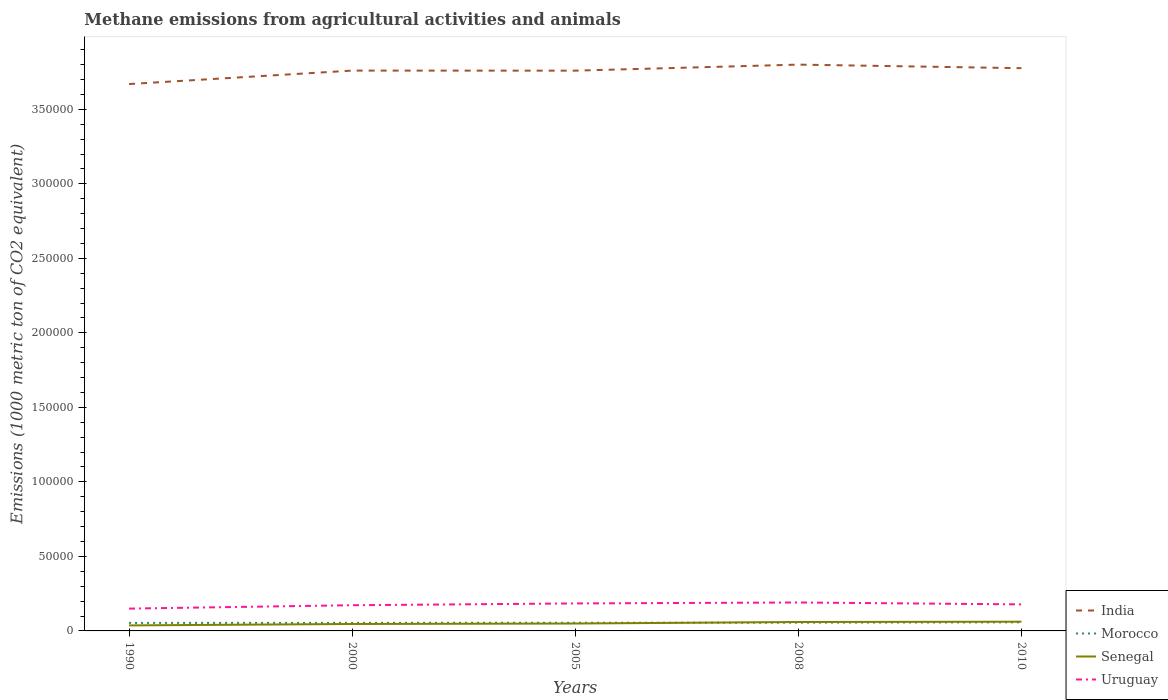Is the number of lines equal to the number of legend labels?
Your answer should be compact. Yes. Across all years, what is the maximum amount of methane emitted in India?
Your answer should be very brief. 3.67e+05. In which year was the amount of methane emitted in India maximum?
Offer a terse response. 1990. What is the total amount of methane emitted in Senegal in the graph?
Provide a short and direct response. -1029.8. What is the difference between the highest and the second highest amount of methane emitted in Uruguay?
Ensure brevity in your answer.  4108.2. What is the difference between the highest and the lowest amount of methane emitted in India?
Your answer should be compact. 4. What is the difference between two consecutive major ticks on the Y-axis?
Your response must be concise. 5.00e+04. Are the values on the major ticks of Y-axis written in scientific E-notation?
Make the answer very short. No. What is the title of the graph?
Your response must be concise. Methane emissions from agricultural activities and animals. Does "Tunisia" appear as one of the legend labels in the graph?
Provide a succinct answer. No. What is the label or title of the Y-axis?
Provide a succinct answer. Emissions (1000 metric ton of CO2 equivalent). What is the Emissions (1000 metric ton of CO2 equivalent) of India in 1990?
Your answer should be very brief. 3.67e+05. What is the Emissions (1000 metric ton of CO2 equivalent) in Morocco in 1990?
Ensure brevity in your answer.  5368.8. What is the Emissions (1000 metric ton of CO2 equivalent) of Senegal in 1990?
Provide a short and direct response. 3695.6. What is the Emissions (1000 metric ton of CO2 equivalent) of Uruguay in 1990?
Make the answer very short. 1.50e+04. What is the Emissions (1000 metric ton of CO2 equivalent) in India in 2000?
Provide a short and direct response. 3.76e+05. What is the Emissions (1000 metric ton of CO2 equivalent) in Morocco in 2000?
Offer a terse response. 5400.3. What is the Emissions (1000 metric ton of CO2 equivalent) in Senegal in 2000?
Your answer should be compact. 4650.7. What is the Emissions (1000 metric ton of CO2 equivalent) in Uruguay in 2000?
Offer a terse response. 1.72e+04. What is the Emissions (1000 metric ton of CO2 equivalent) in India in 2005?
Your answer should be compact. 3.76e+05. What is the Emissions (1000 metric ton of CO2 equivalent) in Morocco in 2005?
Your answer should be very brief. 5471.4. What is the Emissions (1000 metric ton of CO2 equivalent) in Senegal in 2005?
Keep it short and to the point. 4955.1. What is the Emissions (1000 metric ton of CO2 equivalent) of Uruguay in 2005?
Offer a very short reply. 1.84e+04. What is the Emissions (1000 metric ton of CO2 equivalent) of India in 2008?
Your response must be concise. 3.80e+05. What is the Emissions (1000 metric ton of CO2 equivalent) of Morocco in 2008?
Your answer should be compact. 5546.4. What is the Emissions (1000 metric ton of CO2 equivalent) in Senegal in 2008?
Keep it short and to the point. 5984.9. What is the Emissions (1000 metric ton of CO2 equivalent) of Uruguay in 2008?
Provide a short and direct response. 1.91e+04. What is the Emissions (1000 metric ton of CO2 equivalent) in India in 2010?
Make the answer very short. 3.78e+05. What is the Emissions (1000 metric ton of CO2 equivalent) of Morocco in 2010?
Offer a very short reply. 5779.1. What is the Emissions (1000 metric ton of CO2 equivalent) in Senegal in 2010?
Ensure brevity in your answer.  6199.1. What is the Emissions (1000 metric ton of CO2 equivalent) in Uruguay in 2010?
Your answer should be very brief. 1.78e+04. Across all years, what is the maximum Emissions (1000 metric ton of CO2 equivalent) in India?
Make the answer very short. 3.80e+05. Across all years, what is the maximum Emissions (1000 metric ton of CO2 equivalent) in Morocco?
Offer a very short reply. 5779.1. Across all years, what is the maximum Emissions (1000 metric ton of CO2 equivalent) in Senegal?
Provide a short and direct response. 6199.1. Across all years, what is the maximum Emissions (1000 metric ton of CO2 equivalent) of Uruguay?
Make the answer very short. 1.91e+04. Across all years, what is the minimum Emissions (1000 metric ton of CO2 equivalent) in India?
Provide a succinct answer. 3.67e+05. Across all years, what is the minimum Emissions (1000 metric ton of CO2 equivalent) of Morocco?
Your answer should be compact. 5368.8. Across all years, what is the minimum Emissions (1000 metric ton of CO2 equivalent) of Senegal?
Keep it short and to the point. 3695.6. Across all years, what is the minimum Emissions (1000 metric ton of CO2 equivalent) in Uruguay?
Offer a terse response. 1.50e+04. What is the total Emissions (1000 metric ton of CO2 equivalent) in India in the graph?
Offer a terse response. 1.88e+06. What is the total Emissions (1000 metric ton of CO2 equivalent) of Morocco in the graph?
Provide a succinct answer. 2.76e+04. What is the total Emissions (1000 metric ton of CO2 equivalent) of Senegal in the graph?
Give a very brief answer. 2.55e+04. What is the total Emissions (1000 metric ton of CO2 equivalent) of Uruguay in the graph?
Keep it short and to the point. 8.75e+04. What is the difference between the Emissions (1000 metric ton of CO2 equivalent) of India in 1990 and that in 2000?
Ensure brevity in your answer.  -9029.4. What is the difference between the Emissions (1000 metric ton of CO2 equivalent) in Morocco in 1990 and that in 2000?
Give a very brief answer. -31.5. What is the difference between the Emissions (1000 metric ton of CO2 equivalent) of Senegal in 1990 and that in 2000?
Your answer should be very brief. -955.1. What is the difference between the Emissions (1000 metric ton of CO2 equivalent) in Uruguay in 1990 and that in 2000?
Offer a terse response. -2267.7. What is the difference between the Emissions (1000 metric ton of CO2 equivalent) of India in 1990 and that in 2005?
Ensure brevity in your answer.  -8983.7. What is the difference between the Emissions (1000 metric ton of CO2 equivalent) in Morocco in 1990 and that in 2005?
Provide a succinct answer. -102.6. What is the difference between the Emissions (1000 metric ton of CO2 equivalent) in Senegal in 1990 and that in 2005?
Make the answer very short. -1259.5. What is the difference between the Emissions (1000 metric ton of CO2 equivalent) in Uruguay in 1990 and that in 2005?
Ensure brevity in your answer.  -3472.5. What is the difference between the Emissions (1000 metric ton of CO2 equivalent) of India in 1990 and that in 2008?
Your answer should be very brief. -1.30e+04. What is the difference between the Emissions (1000 metric ton of CO2 equivalent) of Morocco in 1990 and that in 2008?
Your answer should be very brief. -177.6. What is the difference between the Emissions (1000 metric ton of CO2 equivalent) of Senegal in 1990 and that in 2008?
Give a very brief answer. -2289.3. What is the difference between the Emissions (1000 metric ton of CO2 equivalent) of Uruguay in 1990 and that in 2008?
Keep it short and to the point. -4108.2. What is the difference between the Emissions (1000 metric ton of CO2 equivalent) in India in 1990 and that in 2010?
Offer a very short reply. -1.06e+04. What is the difference between the Emissions (1000 metric ton of CO2 equivalent) in Morocco in 1990 and that in 2010?
Give a very brief answer. -410.3. What is the difference between the Emissions (1000 metric ton of CO2 equivalent) in Senegal in 1990 and that in 2010?
Offer a very short reply. -2503.5. What is the difference between the Emissions (1000 metric ton of CO2 equivalent) of Uruguay in 1990 and that in 2010?
Offer a very short reply. -2833.1. What is the difference between the Emissions (1000 metric ton of CO2 equivalent) in India in 2000 and that in 2005?
Offer a terse response. 45.7. What is the difference between the Emissions (1000 metric ton of CO2 equivalent) of Morocco in 2000 and that in 2005?
Provide a short and direct response. -71.1. What is the difference between the Emissions (1000 metric ton of CO2 equivalent) in Senegal in 2000 and that in 2005?
Offer a terse response. -304.4. What is the difference between the Emissions (1000 metric ton of CO2 equivalent) of Uruguay in 2000 and that in 2005?
Provide a succinct answer. -1204.8. What is the difference between the Emissions (1000 metric ton of CO2 equivalent) in India in 2000 and that in 2008?
Provide a succinct answer. -4005.8. What is the difference between the Emissions (1000 metric ton of CO2 equivalent) in Morocco in 2000 and that in 2008?
Make the answer very short. -146.1. What is the difference between the Emissions (1000 metric ton of CO2 equivalent) of Senegal in 2000 and that in 2008?
Offer a very short reply. -1334.2. What is the difference between the Emissions (1000 metric ton of CO2 equivalent) of Uruguay in 2000 and that in 2008?
Ensure brevity in your answer.  -1840.5. What is the difference between the Emissions (1000 metric ton of CO2 equivalent) of India in 2000 and that in 2010?
Offer a terse response. -1614.3. What is the difference between the Emissions (1000 metric ton of CO2 equivalent) of Morocco in 2000 and that in 2010?
Your answer should be very brief. -378.8. What is the difference between the Emissions (1000 metric ton of CO2 equivalent) in Senegal in 2000 and that in 2010?
Keep it short and to the point. -1548.4. What is the difference between the Emissions (1000 metric ton of CO2 equivalent) of Uruguay in 2000 and that in 2010?
Your answer should be very brief. -565.4. What is the difference between the Emissions (1000 metric ton of CO2 equivalent) in India in 2005 and that in 2008?
Provide a short and direct response. -4051.5. What is the difference between the Emissions (1000 metric ton of CO2 equivalent) in Morocco in 2005 and that in 2008?
Your answer should be very brief. -75. What is the difference between the Emissions (1000 metric ton of CO2 equivalent) in Senegal in 2005 and that in 2008?
Make the answer very short. -1029.8. What is the difference between the Emissions (1000 metric ton of CO2 equivalent) of Uruguay in 2005 and that in 2008?
Your response must be concise. -635.7. What is the difference between the Emissions (1000 metric ton of CO2 equivalent) of India in 2005 and that in 2010?
Your response must be concise. -1660. What is the difference between the Emissions (1000 metric ton of CO2 equivalent) of Morocco in 2005 and that in 2010?
Offer a terse response. -307.7. What is the difference between the Emissions (1000 metric ton of CO2 equivalent) of Senegal in 2005 and that in 2010?
Offer a very short reply. -1244. What is the difference between the Emissions (1000 metric ton of CO2 equivalent) of Uruguay in 2005 and that in 2010?
Give a very brief answer. 639.4. What is the difference between the Emissions (1000 metric ton of CO2 equivalent) of India in 2008 and that in 2010?
Offer a very short reply. 2391.5. What is the difference between the Emissions (1000 metric ton of CO2 equivalent) of Morocco in 2008 and that in 2010?
Your response must be concise. -232.7. What is the difference between the Emissions (1000 metric ton of CO2 equivalent) in Senegal in 2008 and that in 2010?
Ensure brevity in your answer.  -214.2. What is the difference between the Emissions (1000 metric ton of CO2 equivalent) in Uruguay in 2008 and that in 2010?
Offer a terse response. 1275.1. What is the difference between the Emissions (1000 metric ton of CO2 equivalent) of India in 1990 and the Emissions (1000 metric ton of CO2 equivalent) of Morocco in 2000?
Ensure brevity in your answer.  3.62e+05. What is the difference between the Emissions (1000 metric ton of CO2 equivalent) of India in 1990 and the Emissions (1000 metric ton of CO2 equivalent) of Senegal in 2000?
Your response must be concise. 3.62e+05. What is the difference between the Emissions (1000 metric ton of CO2 equivalent) of India in 1990 and the Emissions (1000 metric ton of CO2 equivalent) of Uruguay in 2000?
Your answer should be compact. 3.50e+05. What is the difference between the Emissions (1000 metric ton of CO2 equivalent) in Morocco in 1990 and the Emissions (1000 metric ton of CO2 equivalent) in Senegal in 2000?
Make the answer very short. 718.1. What is the difference between the Emissions (1000 metric ton of CO2 equivalent) of Morocco in 1990 and the Emissions (1000 metric ton of CO2 equivalent) of Uruguay in 2000?
Keep it short and to the point. -1.19e+04. What is the difference between the Emissions (1000 metric ton of CO2 equivalent) of Senegal in 1990 and the Emissions (1000 metric ton of CO2 equivalent) of Uruguay in 2000?
Offer a very short reply. -1.35e+04. What is the difference between the Emissions (1000 metric ton of CO2 equivalent) of India in 1990 and the Emissions (1000 metric ton of CO2 equivalent) of Morocco in 2005?
Keep it short and to the point. 3.61e+05. What is the difference between the Emissions (1000 metric ton of CO2 equivalent) in India in 1990 and the Emissions (1000 metric ton of CO2 equivalent) in Senegal in 2005?
Your response must be concise. 3.62e+05. What is the difference between the Emissions (1000 metric ton of CO2 equivalent) in India in 1990 and the Emissions (1000 metric ton of CO2 equivalent) in Uruguay in 2005?
Provide a succinct answer. 3.48e+05. What is the difference between the Emissions (1000 metric ton of CO2 equivalent) of Morocco in 1990 and the Emissions (1000 metric ton of CO2 equivalent) of Senegal in 2005?
Your answer should be compact. 413.7. What is the difference between the Emissions (1000 metric ton of CO2 equivalent) of Morocco in 1990 and the Emissions (1000 metric ton of CO2 equivalent) of Uruguay in 2005?
Offer a terse response. -1.31e+04. What is the difference between the Emissions (1000 metric ton of CO2 equivalent) of Senegal in 1990 and the Emissions (1000 metric ton of CO2 equivalent) of Uruguay in 2005?
Your response must be concise. -1.48e+04. What is the difference between the Emissions (1000 metric ton of CO2 equivalent) of India in 1990 and the Emissions (1000 metric ton of CO2 equivalent) of Morocco in 2008?
Your answer should be compact. 3.61e+05. What is the difference between the Emissions (1000 metric ton of CO2 equivalent) of India in 1990 and the Emissions (1000 metric ton of CO2 equivalent) of Senegal in 2008?
Give a very brief answer. 3.61e+05. What is the difference between the Emissions (1000 metric ton of CO2 equivalent) of India in 1990 and the Emissions (1000 metric ton of CO2 equivalent) of Uruguay in 2008?
Your answer should be compact. 3.48e+05. What is the difference between the Emissions (1000 metric ton of CO2 equivalent) of Morocco in 1990 and the Emissions (1000 metric ton of CO2 equivalent) of Senegal in 2008?
Your response must be concise. -616.1. What is the difference between the Emissions (1000 metric ton of CO2 equivalent) of Morocco in 1990 and the Emissions (1000 metric ton of CO2 equivalent) of Uruguay in 2008?
Give a very brief answer. -1.37e+04. What is the difference between the Emissions (1000 metric ton of CO2 equivalent) of Senegal in 1990 and the Emissions (1000 metric ton of CO2 equivalent) of Uruguay in 2008?
Provide a short and direct response. -1.54e+04. What is the difference between the Emissions (1000 metric ton of CO2 equivalent) in India in 1990 and the Emissions (1000 metric ton of CO2 equivalent) in Morocco in 2010?
Keep it short and to the point. 3.61e+05. What is the difference between the Emissions (1000 metric ton of CO2 equivalent) in India in 1990 and the Emissions (1000 metric ton of CO2 equivalent) in Senegal in 2010?
Offer a very short reply. 3.61e+05. What is the difference between the Emissions (1000 metric ton of CO2 equivalent) of India in 1990 and the Emissions (1000 metric ton of CO2 equivalent) of Uruguay in 2010?
Provide a short and direct response. 3.49e+05. What is the difference between the Emissions (1000 metric ton of CO2 equivalent) of Morocco in 1990 and the Emissions (1000 metric ton of CO2 equivalent) of Senegal in 2010?
Make the answer very short. -830.3. What is the difference between the Emissions (1000 metric ton of CO2 equivalent) of Morocco in 1990 and the Emissions (1000 metric ton of CO2 equivalent) of Uruguay in 2010?
Ensure brevity in your answer.  -1.24e+04. What is the difference between the Emissions (1000 metric ton of CO2 equivalent) in Senegal in 1990 and the Emissions (1000 metric ton of CO2 equivalent) in Uruguay in 2010?
Your answer should be very brief. -1.41e+04. What is the difference between the Emissions (1000 metric ton of CO2 equivalent) of India in 2000 and the Emissions (1000 metric ton of CO2 equivalent) of Morocco in 2005?
Offer a terse response. 3.71e+05. What is the difference between the Emissions (1000 metric ton of CO2 equivalent) of India in 2000 and the Emissions (1000 metric ton of CO2 equivalent) of Senegal in 2005?
Keep it short and to the point. 3.71e+05. What is the difference between the Emissions (1000 metric ton of CO2 equivalent) of India in 2000 and the Emissions (1000 metric ton of CO2 equivalent) of Uruguay in 2005?
Your answer should be compact. 3.58e+05. What is the difference between the Emissions (1000 metric ton of CO2 equivalent) of Morocco in 2000 and the Emissions (1000 metric ton of CO2 equivalent) of Senegal in 2005?
Your answer should be very brief. 445.2. What is the difference between the Emissions (1000 metric ton of CO2 equivalent) in Morocco in 2000 and the Emissions (1000 metric ton of CO2 equivalent) in Uruguay in 2005?
Offer a terse response. -1.30e+04. What is the difference between the Emissions (1000 metric ton of CO2 equivalent) in Senegal in 2000 and the Emissions (1000 metric ton of CO2 equivalent) in Uruguay in 2005?
Keep it short and to the point. -1.38e+04. What is the difference between the Emissions (1000 metric ton of CO2 equivalent) of India in 2000 and the Emissions (1000 metric ton of CO2 equivalent) of Morocco in 2008?
Offer a terse response. 3.70e+05. What is the difference between the Emissions (1000 metric ton of CO2 equivalent) in India in 2000 and the Emissions (1000 metric ton of CO2 equivalent) in Senegal in 2008?
Your answer should be compact. 3.70e+05. What is the difference between the Emissions (1000 metric ton of CO2 equivalent) of India in 2000 and the Emissions (1000 metric ton of CO2 equivalent) of Uruguay in 2008?
Offer a very short reply. 3.57e+05. What is the difference between the Emissions (1000 metric ton of CO2 equivalent) in Morocco in 2000 and the Emissions (1000 metric ton of CO2 equivalent) in Senegal in 2008?
Offer a terse response. -584.6. What is the difference between the Emissions (1000 metric ton of CO2 equivalent) of Morocco in 2000 and the Emissions (1000 metric ton of CO2 equivalent) of Uruguay in 2008?
Your response must be concise. -1.37e+04. What is the difference between the Emissions (1000 metric ton of CO2 equivalent) in Senegal in 2000 and the Emissions (1000 metric ton of CO2 equivalent) in Uruguay in 2008?
Ensure brevity in your answer.  -1.44e+04. What is the difference between the Emissions (1000 metric ton of CO2 equivalent) in India in 2000 and the Emissions (1000 metric ton of CO2 equivalent) in Morocco in 2010?
Give a very brief answer. 3.70e+05. What is the difference between the Emissions (1000 metric ton of CO2 equivalent) in India in 2000 and the Emissions (1000 metric ton of CO2 equivalent) in Senegal in 2010?
Provide a succinct answer. 3.70e+05. What is the difference between the Emissions (1000 metric ton of CO2 equivalent) of India in 2000 and the Emissions (1000 metric ton of CO2 equivalent) of Uruguay in 2010?
Give a very brief answer. 3.58e+05. What is the difference between the Emissions (1000 metric ton of CO2 equivalent) of Morocco in 2000 and the Emissions (1000 metric ton of CO2 equivalent) of Senegal in 2010?
Offer a very short reply. -798.8. What is the difference between the Emissions (1000 metric ton of CO2 equivalent) in Morocco in 2000 and the Emissions (1000 metric ton of CO2 equivalent) in Uruguay in 2010?
Make the answer very short. -1.24e+04. What is the difference between the Emissions (1000 metric ton of CO2 equivalent) in Senegal in 2000 and the Emissions (1000 metric ton of CO2 equivalent) in Uruguay in 2010?
Offer a very short reply. -1.32e+04. What is the difference between the Emissions (1000 metric ton of CO2 equivalent) in India in 2005 and the Emissions (1000 metric ton of CO2 equivalent) in Morocco in 2008?
Provide a succinct answer. 3.70e+05. What is the difference between the Emissions (1000 metric ton of CO2 equivalent) in India in 2005 and the Emissions (1000 metric ton of CO2 equivalent) in Senegal in 2008?
Give a very brief answer. 3.70e+05. What is the difference between the Emissions (1000 metric ton of CO2 equivalent) of India in 2005 and the Emissions (1000 metric ton of CO2 equivalent) of Uruguay in 2008?
Provide a short and direct response. 3.57e+05. What is the difference between the Emissions (1000 metric ton of CO2 equivalent) of Morocco in 2005 and the Emissions (1000 metric ton of CO2 equivalent) of Senegal in 2008?
Make the answer very short. -513.5. What is the difference between the Emissions (1000 metric ton of CO2 equivalent) of Morocco in 2005 and the Emissions (1000 metric ton of CO2 equivalent) of Uruguay in 2008?
Offer a terse response. -1.36e+04. What is the difference between the Emissions (1000 metric ton of CO2 equivalent) in Senegal in 2005 and the Emissions (1000 metric ton of CO2 equivalent) in Uruguay in 2008?
Your answer should be very brief. -1.41e+04. What is the difference between the Emissions (1000 metric ton of CO2 equivalent) in India in 2005 and the Emissions (1000 metric ton of CO2 equivalent) in Morocco in 2010?
Ensure brevity in your answer.  3.70e+05. What is the difference between the Emissions (1000 metric ton of CO2 equivalent) in India in 2005 and the Emissions (1000 metric ton of CO2 equivalent) in Senegal in 2010?
Your answer should be compact. 3.70e+05. What is the difference between the Emissions (1000 metric ton of CO2 equivalent) of India in 2005 and the Emissions (1000 metric ton of CO2 equivalent) of Uruguay in 2010?
Provide a short and direct response. 3.58e+05. What is the difference between the Emissions (1000 metric ton of CO2 equivalent) of Morocco in 2005 and the Emissions (1000 metric ton of CO2 equivalent) of Senegal in 2010?
Make the answer very short. -727.7. What is the difference between the Emissions (1000 metric ton of CO2 equivalent) of Morocco in 2005 and the Emissions (1000 metric ton of CO2 equivalent) of Uruguay in 2010?
Your response must be concise. -1.23e+04. What is the difference between the Emissions (1000 metric ton of CO2 equivalent) of Senegal in 2005 and the Emissions (1000 metric ton of CO2 equivalent) of Uruguay in 2010?
Offer a very short reply. -1.29e+04. What is the difference between the Emissions (1000 metric ton of CO2 equivalent) in India in 2008 and the Emissions (1000 metric ton of CO2 equivalent) in Morocco in 2010?
Your response must be concise. 3.74e+05. What is the difference between the Emissions (1000 metric ton of CO2 equivalent) in India in 2008 and the Emissions (1000 metric ton of CO2 equivalent) in Senegal in 2010?
Make the answer very short. 3.74e+05. What is the difference between the Emissions (1000 metric ton of CO2 equivalent) of India in 2008 and the Emissions (1000 metric ton of CO2 equivalent) of Uruguay in 2010?
Make the answer very short. 3.62e+05. What is the difference between the Emissions (1000 metric ton of CO2 equivalent) of Morocco in 2008 and the Emissions (1000 metric ton of CO2 equivalent) of Senegal in 2010?
Offer a very short reply. -652.7. What is the difference between the Emissions (1000 metric ton of CO2 equivalent) of Morocco in 2008 and the Emissions (1000 metric ton of CO2 equivalent) of Uruguay in 2010?
Your response must be concise. -1.23e+04. What is the difference between the Emissions (1000 metric ton of CO2 equivalent) of Senegal in 2008 and the Emissions (1000 metric ton of CO2 equivalent) of Uruguay in 2010?
Provide a succinct answer. -1.18e+04. What is the average Emissions (1000 metric ton of CO2 equivalent) of India per year?
Offer a very short reply. 3.75e+05. What is the average Emissions (1000 metric ton of CO2 equivalent) in Morocco per year?
Make the answer very short. 5513.2. What is the average Emissions (1000 metric ton of CO2 equivalent) of Senegal per year?
Keep it short and to the point. 5097.08. What is the average Emissions (1000 metric ton of CO2 equivalent) of Uruguay per year?
Offer a very short reply. 1.75e+04. In the year 1990, what is the difference between the Emissions (1000 metric ton of CO2 equivalent) of India and Emissions (1000 metric ton of CO2 equivalent) of Morocco?
Your answer should be very brief. 3.62e+05. In the year 1990, what is the difference between the Emissions (1000 metric ton of CO2 equivalent) in India and Emissions (1000 metric ton of CO2 equivalent) in Senegal?
Your answer should be compact. 3.63e+05. In the year 1990, what is the difference between the Emissions (1000 metric ton of CO2 equivalent) in India and Emissions (1000 metric ton of CO2 equivalent) in Uruguay?
Give a very brief answer. 3.52e+05. In the year 1990, what is the difference between the Emissions (1000 metric ton of CO2 equivalent) of Morocco and Emissions (1000 metric ton of CO2 equivalent) of Senegal?
Ensure brevity in your answer.  1673.2. In the year 1990, what is the difference between the Emissions (1000 metric ton of CO2 equivalent) of Morocco and Emissions (1000 metric ton of CO2 equivalent) of Uruguay?
Offer a terse response. -9604.5. In the year 1990, what is the difference between the Emissions (1000 metric ton of CO2 equivalent) of Senegal and Emissions (1000 metric ton of CO2 equivalent) of Uruguay?
Ensure brevity in your answer.  -1.13e+04. In the year 2000, what is the difference between the Emissions (1000 metric ton of CO2 equivalent) of India and Emissions (1000 metric ton of CO2 equivalent) of Morocco?
Provide a succinct answer. 3.71e+05. In the year 2000, what is the difference between the Emissions (1000 metric ton of CO2 equivalent) of India and Emissions (1000 metric ton of CO2 equivalent) of Senegal?
Make the answer very short. 3.71e+05. In the year 2000, what is the difference between the Emissions (1000 metric ton of CO2 equivalent) of India and Emissions (1000 metric ton of CO2 equivalent) of Uruguay?
Your answer should be very brief. 3.59e+05. In the year 2000, what is the difference between the Emissions (1000 metric ton of CO2 equivalent) of Morocco and Emissions (1000 metric ton of CO2 equivalent) of Senegal?
Keep it short and to the point. 749.6. In the year 2000, what is the difference between the Emissions (1000 metric ton of CO2 equivalent) of Morocco and Emissions (1000 metric ton of CO2 equivalent) of Uruguay?
Offer a terse response. -1.18e+04. In the year 2000, what is the difference between the Emissions (1000 metric ton of CO2 equivalent) of Senegal and Emissions (1000 metric ton of CO2 equivalent) of Uruguay?
Provide a short and direct response. -1.26e+04. In the year 2005, what is the difference between the Emissions (1000 metric ton of CO2 equivalent) in India and Emissions (1000 metric ton of CO2 equivalent) in Morocco?
Keep it short and to the point. 3.70e+05. In the year 2005, what is the difference between the Emissions (1000 metric ton of CO2 equivalent) in India and Emissions (1000 metric ton of CO2 equivalent) in Senegal?
Your answer should be compact. 3.71e+05. In the year 2005, what is the difference between the Emissions (1000 metric ton of CO2 equivalent) in India and Emissions (1000 metric ton of CO2 equivalent) in Uruguay?
Your answer should be very brief. 3.57e+05. In the year 2005, what is the difference between the Emissions (1000 metric ton of CO2 equivalent) of Morocco and Emissions (1000 metric ton of CO2 equivalent) of Senegal?
Offer a terse response. 516.3. In the year 2005, what is the difference between the Emissions (1000 metric ton of CO2 equivalent) in Morocco and Emissions (1000 metric ton of CO2 equivalent) in Uruguay?
Provide a short and direct response. -1.30e+04. In the year 2005, what is the difference between the Emissions (1000 metric ton of CO2 equivalent) in Senegal and Emissions (1000 metric ton of CO2 equivalent) in Uruguay?
Your answer should be very brief. -1.35e+04. In the year 2008, what is the difference between the Emissions (1000 metric ton of CO2 equivalent) in India and Emissions (1000 metric ton of CO2 equivalent) in Morocco?
Offer a very short reply. 3.74e+05. In the year 2008, what is the difference between the Emissions (1000 metric ton of CO2 equivalent) of India and Emissions (1000 metric ton of CO2 equivalent) of Senegal?
Offer a terse response. 3.74e+05. In the year 2008, what is the difference between the Emissions (1000 metric ton of CO2 equivalent) in India and Emissions (1000 metric ton of CO2 equivalent) in Uruguay?
Keep it short and to the point. 3.61e+05. In the year 2008, what is the difference between the Emissions (1000 metric ton of CO2 equivalent) of Morocco and Emissions (1000 metric ton of CO2 equivalent) of Senegal?
Your answer should be very brief. -438.5. In the year 2008, what is the difference between the Emissions (1000 metric ton of CO2 equivalent) of Morocco and Emissions (1000 metric ton of CO2 equivalent) of Uruguay?
Keep it short and to the point. -1.35e+04. In the year 2008, what is the difference between the Emissions (1000 metric ton of CO2 equivalent) of Senegal and Emissions (1000 metric ton of CO2 equivalent) of Uruguay?
Provide a short and direct response. -1.31e+04. In the year 2010, what is the difference between the Emissions (1000 metric ton of CO2 equivalent) in India and Emissions (1000 metric ton of CO2 equivalent) in Morocco?
Give a very brief answer. 3.72e+05. In the year 2010, what is the difference between the Emissions (1000 metric ton of CO2 equivalent) in India and Emissions (1000 metric ton of CO2 equivalent) in Senegal?
Provide a succinct answer. 3.71e+05. In the year 2010, what is the difference between the Emissions (1000 metric ton of CO2 equivalent) in India and Emissions (1000 metric ton of CO2 equivalent) in Uruguay?
Give a very brief answer. 3.60e+05. In the year 2010, what is the difference between the Emissions (1000 metric ton of CO2 equivalent) of Morocco and Emissions (1000 metric ton of CO2 equivalent) of Senegal?
Your answer should be compact. -420. In the year 2010, what is the difference between the Emissions (1000 metric ton of CO2 equivalent) in Morocco and Emissions (1000 metric ton of CO2 equivalent) in Uruguay?
Offer a very short reply. -1.20e+04. In the year 2010, what is the difference between the Emissions (1000 metric ton of CO2 equivalent) of Senegal and Emissions (1000 metric ton of CO2 equivalent) of Uruguay?
Your response must be concise. -1.16e+04. What is the ratio of the Emissions (1000 metric ton of CO2 equivalent) in Senegal in 1990 to that in 2000?
Make the answer very short. 0.79. What is the ratio of the Emissions (1000 metric ton of CO2 equivalent) in Uruguay in 1990 to that in 2000?
Provide a short and direct response. 0.87. What is the ratio of the Emissions (1000 metric ton of CO2 equivalent) in India in 1990 to that in 2005?
Ensure brevity in your answer.  0.98. What is the ratio of the Emissions (1000 metric ton of CO2 equivalent) in Morocco in 1990 to that in 2005?
Your answer should be compact. 0.98. What is the ratio of the Emissions (1000 metric ton of CO2 equivalent) in Senegal in 1990 to that in 2005?
Provide a succinct answer. 0.75. What is the ratio of the Emissions (1000 metric ton of CO2 equivalent) of Uruguay in 1990 to that in 2005?
Make the answer very short. 0.81. What is the ratio of the Emissions (1000 metric ton of CO2 equivalent) of India in 1990 to that in 2008?
Provide a short and direct response. 0.97. What is the ratio of the Emissions (1000 metric ton of CO2 equivalent) of Morocco in 1990 to that in 2008?
Offer a terse response. 0.97. What is the ratio of the Emissions (1000 metric ton of CO2 equivalent) in Senegal in 1990 to that in 2008?
Keep it short and to the point. 0.62. What is the ratio of the Emissions (1000 metric ton of CO2 equivalent) in Uruguay in 1990 to that in 2008?
Keep it short and to the point. 0.78. What is the ratio of the Emissions (1000 metric ton of CO2 equivalent) of India in 1990 to that in 2010?
Offer a terse response. 0.97. What is the ratio of the Emissions (1000 metric ton of CO2 equivalent) in Morocco in 1990 to that in 2010?
Your answer should be very brief. 0.93. What is the ratio of the Emissions (1000 metric ton of CO2 equivalent) in Senegal in 1990 to that in 2010?
Keep it short and to the point. 0.6. What is the ratio of the Emissions (1000 metric ton of CO2 equivalent) of Uruguay in 1990 to that in 2010?
Ensure brevity in your answer.  0.84. What is the ratio of the Emissions (1000 metric ton of CO2 equivalent) in Senegal in 2000 to that in 2005?
Offer a very short reply. 0.94. What is the ratio of the Emissions (1000 metric ton of CO2 equivalent) of Uruguay in 2000 to that in 2005?
Provide a succinct answer. 0.93. What is the ratio of the Emissions (1000 metric ton of CO2 equivalent) in Morocco in 2000 to that in 2008?
Your response must be concise. 0.97. What is the ratio of the Emissions (1000 metric ton of CO2 equivalent) of Senegal in 2000 to that in 2008?
Your answer should be compact. 0.78. What is the ratio of the Emissions (1000 metric ton of CO2 equivalent) of Uruguay in 2000 to that in 2008?
Provide a succinct answer. 0.9. What is the ratio of the Emissions (1000 metric ton of CO2 equivalent) of Morocco in 2000 to that in 2010?
Provide a succinct answer. 0.93. What is the ratio of the Emissions (1000 metric ton of CO2 equivalent) in Senegal in 2000 to that in 2010?
Ensure brevity in your answer.  0.75. What is the ratio of the Emissions (1000 metric ton of CO2 equivalent) of Uruguay in 2000 to that in 2010?
Keep it short and to the point. 0.97. What is the ratio of the Emissions (1000 metric ton of CO2 equivalent) of India in 2005 to that in 2008?
Offer a terse response. 0.99. What is the ratio of the Emissions (1000 metric ton of CO2 equivalent) in Morocco in 2005 to that in 2008?
Ensure brevity in your answer.  0.99. What is the ratio of the Emissions (1000 metric ton of CO2 equivalent) of Senegal in 2005 to that in 2008?
Make the answer very short. 0.83. What is the ratio of the Emissions (1000 metric ton of CO2 equivalent) in Uruguay in 2005 to that in 2008?
Your answer should be compact. 0.97. What is the ratio of the Emissions (1000 metric ton of CO2 equivalent) in India in 2005 to that in 2010?
Offer a very short reply. 1. What is the ratio of the Emissions (1000 metric ton of CO2 equivalent) in Morocco in 2005 to that in 2010?
Give a very brief answer. 0.95. What is the ratio of the Emissions (1000 metric ton of CO2 equivalent) of Senegal in 2005 to that in 2010?
Offer a terse response. 0.8. What is the ratio of the Emissions (1000 metric ton of CO2 equivalent) of Uruguay in 2005 to that in 2010?
Your answer should be very brief. 1.04. What is the ratio of the Emissions (1000 metric ton of CO2 equivalent) in India in 2008 to that in 2010?
Provide a succinct answer. 1.01. What is the ratio of the Emissions (1000 metric ton of CO2 equivalent) in Morocco in 2008 to that in 2010?
Give a very brief answer. 0.96. What is the ratio of the Emissions (1000 metric ton of CO2 equivalent) in Senegal in 2008 to that in 2010?
Offer a terse response. 0.97. What is the ratio of the Emissions (1000 metric ton of CO2 equivalent) of Uruguay in 2008 to that in 2010?
Ensure brevity in your answer.  1.07. What is the difference between the highest and the second highest Emissions (1000 metric ton of CO2 equivalent) of India?
Your answer should be very brief. 2391.5. What is the difference between the highest and the second highest Emissions (1000 metric ton of CO2 equivalent) of Morocco?
Provide a succinct answer. 232.7. What is the difference between the highest and the second highest Emissions (1000 metric ton of CO2 equivalent) in Senegal?
Your response must be concise. 214.2. What is the difference between the highest and the second highest Emissions (1000 metric ton of CO2 equivalent) in Uruguay?
Keep it short and to the point. 635.7. What is the difference between the highest and the lowest Emissions (1000 metric ton of CO2 equivalent) in India?
Your answer should be very brief. 1.30e+04. What is the difference between the highest and the lowest Emissions (1000 metric ton of CO2 equivalent) in Morocco?
Offer a very short reply. 410.3. What is the difference between the highest and the lowest Emissions (1000 metric ton of CO2 equivalent) in Senegal?
Provide a short and direct response. 2503.5. What is the difference between the highest and the lowest Emissions (1000 metric ton of CO2 equivalent) of Uruguay?
Offer a very short reply. 4108.2. 